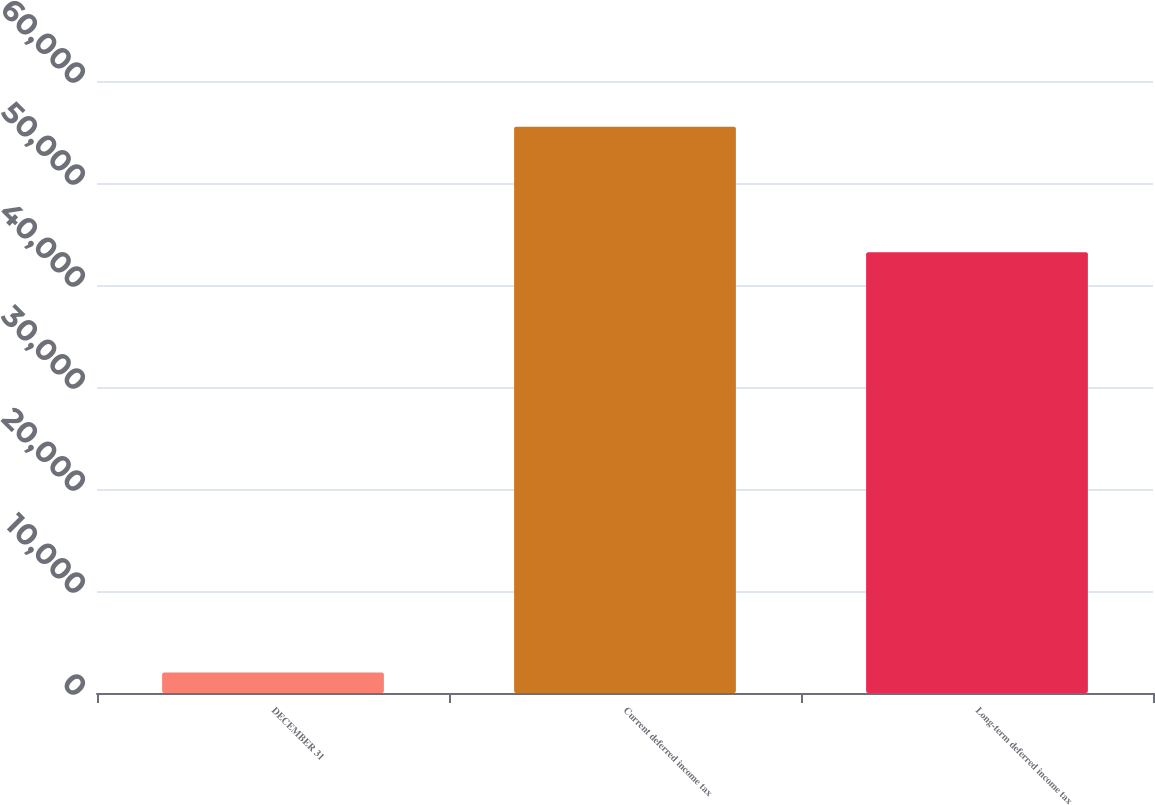Convert chart. <chart><loc_0><loc_0><loc_500><loc_500><bar_chart><fcel>DECEMBER 31<fcel>Current deferred income tax<fcel>Long-term deferred income tax<nl><fcel>2007<fcel>55522<fcel>43206<nl></chart> 